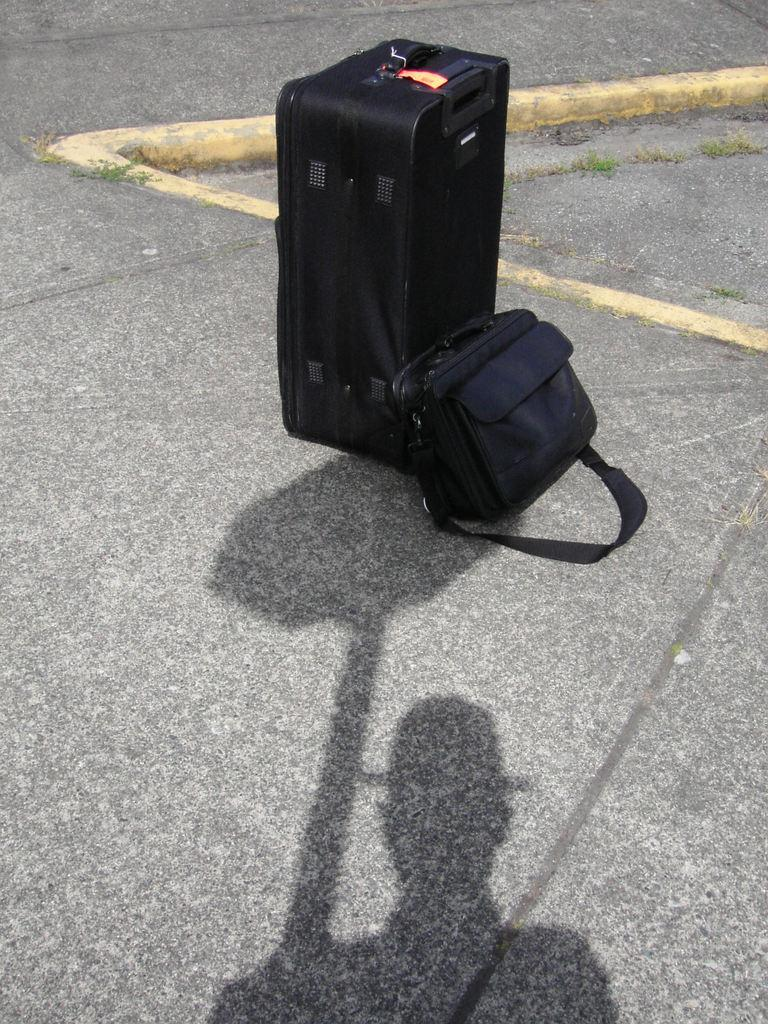What is the main feature of the image? There is a road in the image. What objects can be seen on the road? There are two bags on the road. Can you describe the person in the image? There is a man wearing a hat in the image. What else is visible in the image related to the man? The man's shadow is visible in the image. What type of books is the man reading in the image? There are no books present in the image; the man is not reading. What kind of music can be heard playing in the background of the image? There is no music present in the image; it is a still image with no sound. 